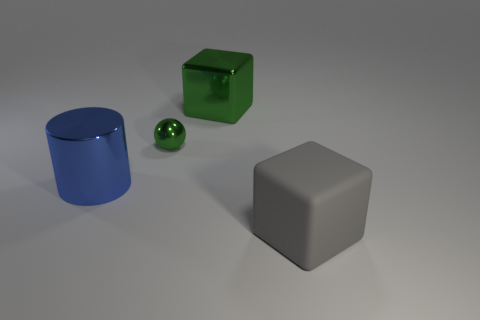Are there any other things that are made of the same material as the big gray cube? Based on the image, it's difficult to determine the exact materials of the objects with certainty. However, the objects, including the big gray cube, the blue cylinder, the green cube, and the green sphere, appear to be computer-generated and share a similar surface finish that could imply they are made of a similar synthetic or plastic-like material in the context of the visualization. 